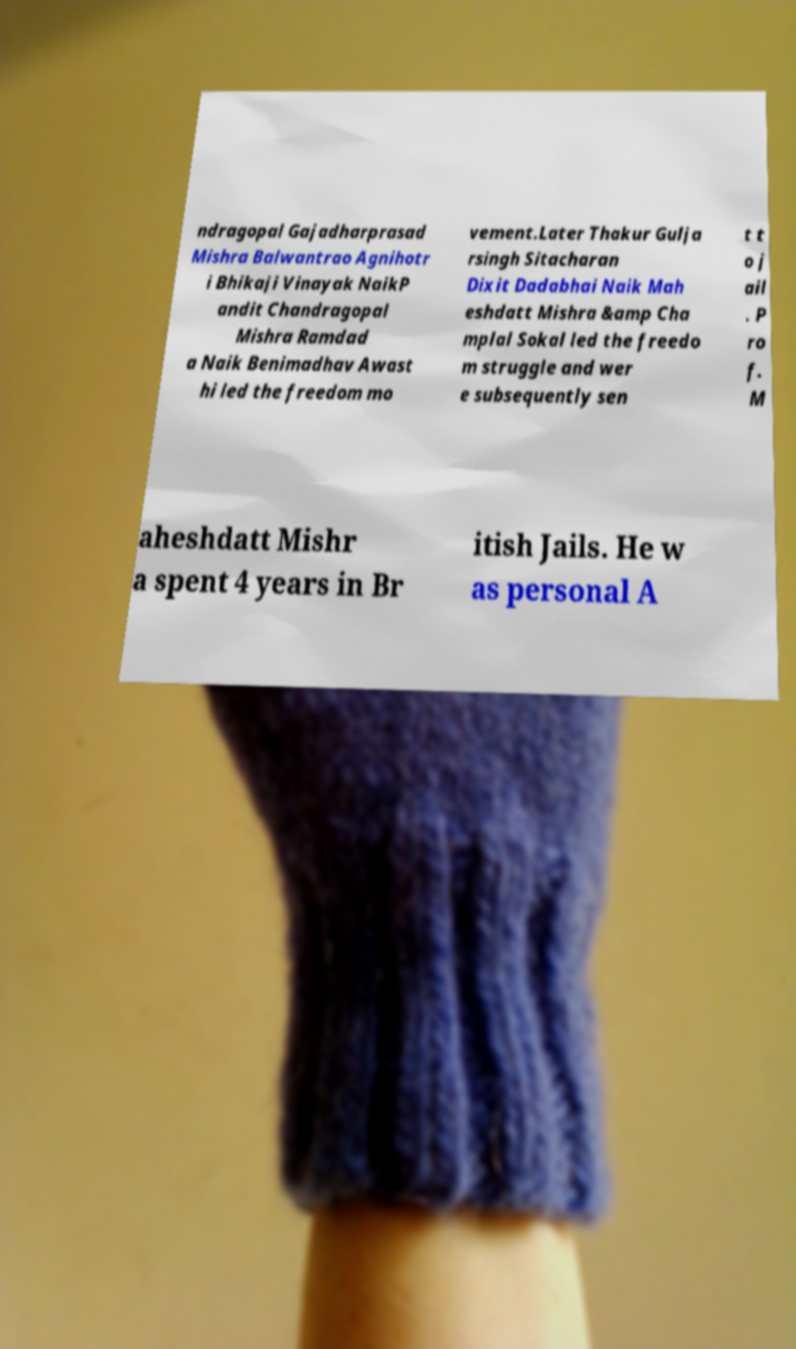Could you assist in decoding the text presented in this image and type it out clearly? ndragopal Gajadharprasad Mishra Balwantrao Agnihotr i Bhikaji Vinayak NaikP andit Chandragopal Mishra Ramdad a Naik Benimadhav Awast hi led the freedom mo vement.Later Thakur Gulja rsingh Sitacharan Dixit Dadabhai Naik Mah eshdatt Mishra &amp Cha mplal Sokal led the freedo m struggle and wer e subsequently sen t t o j ail . P ro f. M aheshdatt Mishr a spent 4 years in Br itish Jails. He w as personal A 